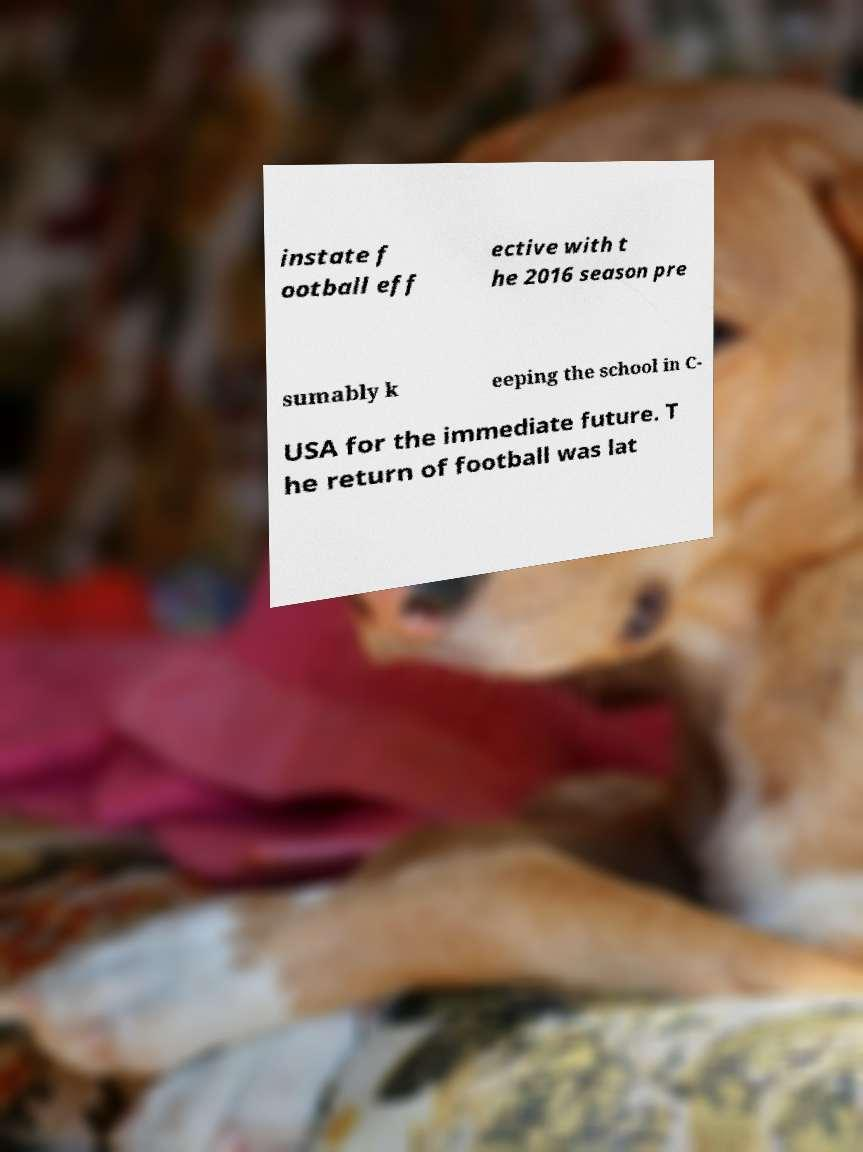What messages or text are displayed in this image? I need them in a readable, typed format. instate f ootball eff ective with t he 2016 season pre sumably k eeping the school in C- USA for the immediate future. T he return of football was lat 